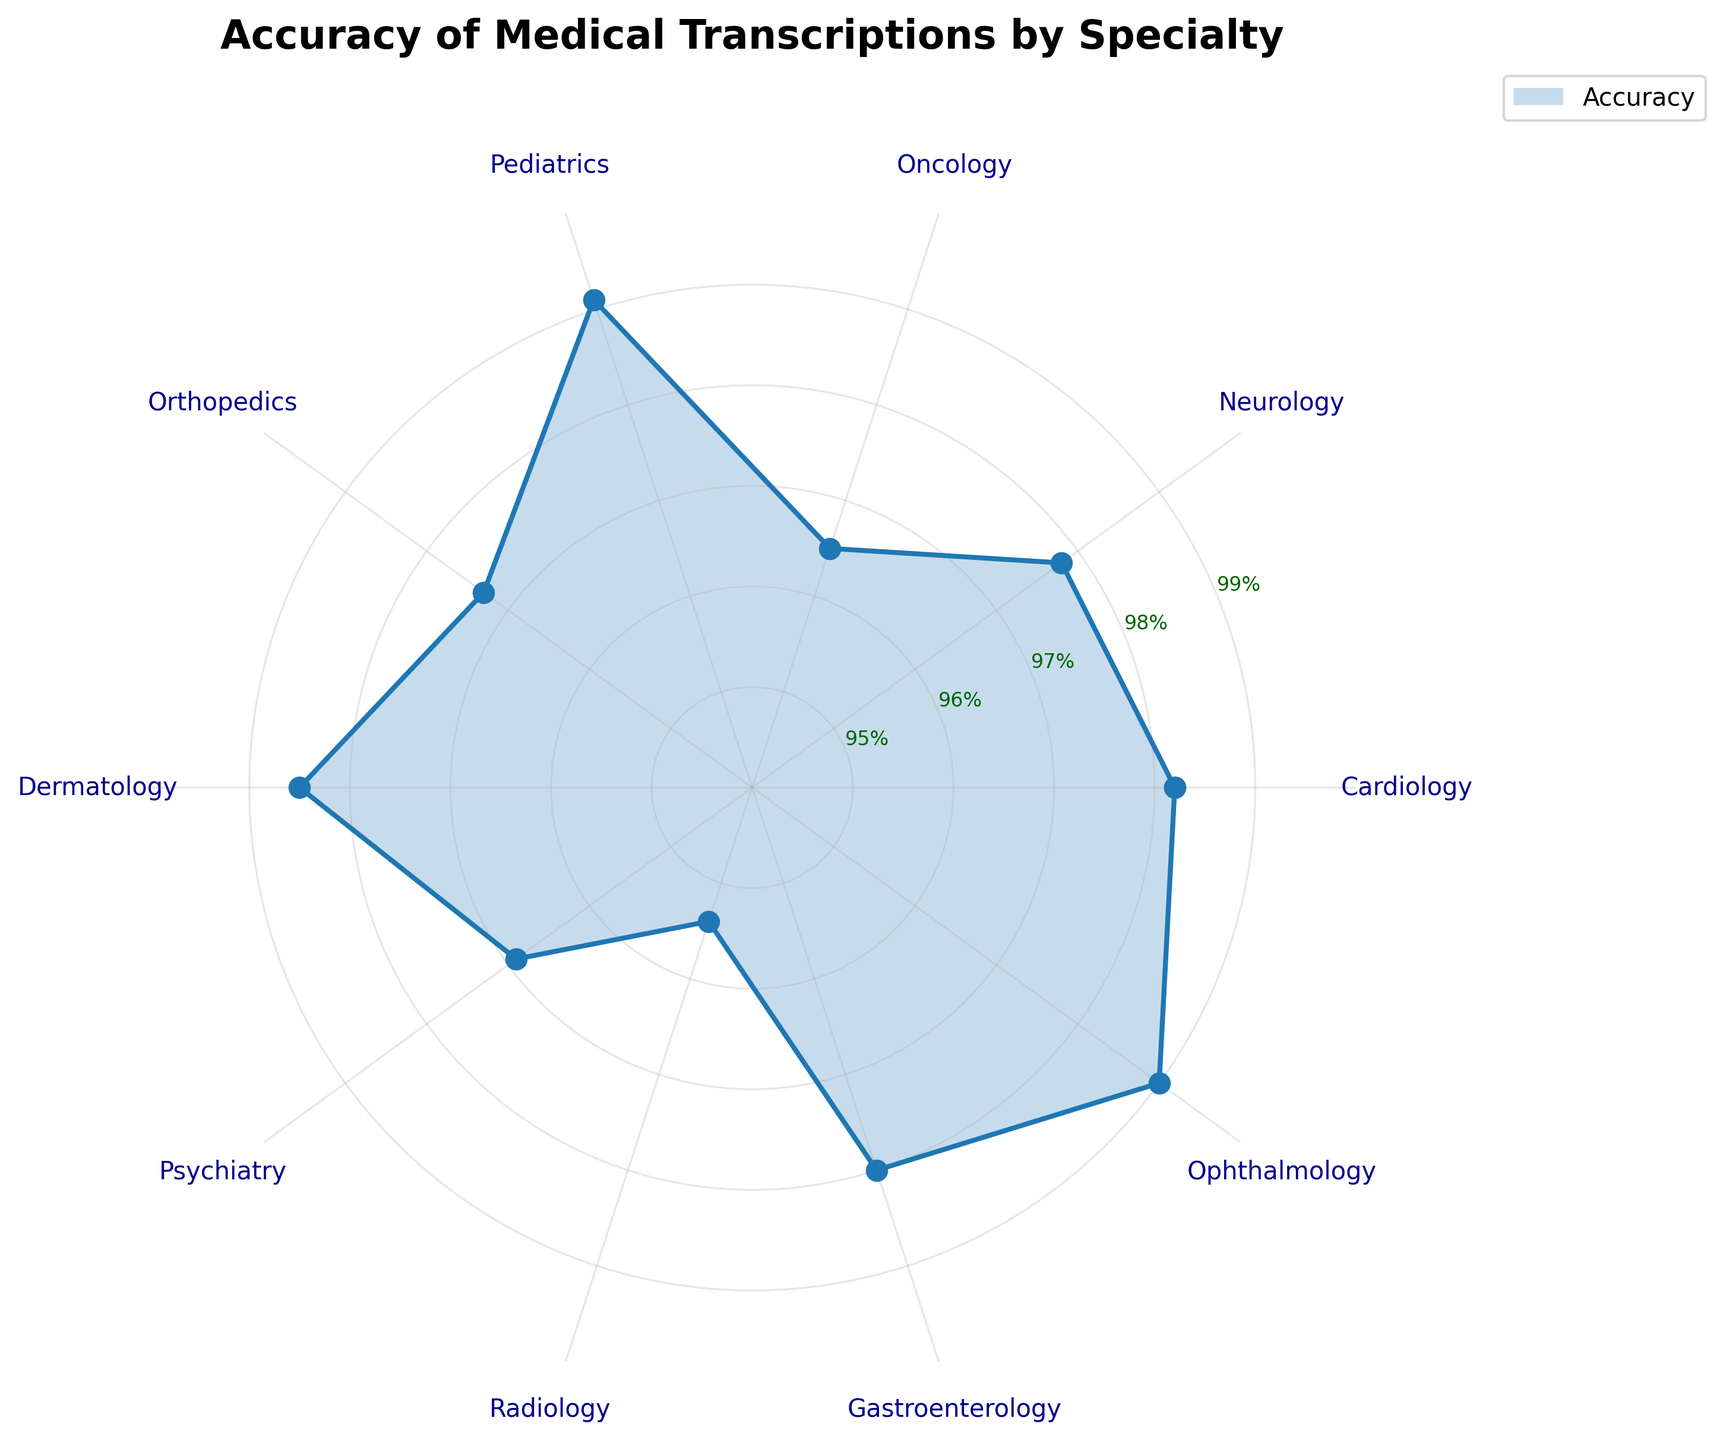What's the title of the figure? The title of the figure is typically displayed at the top and provides a summary of the chart's purpose.
Answer: Accuracy of Medical Transcriptions by Specialty How many medical specialties are represented in the figure? By counting the number of labels around the polar plot, one can see there are 10 different specialties represented.
Answer: 10 Which medical specialty has the highest accuracy in medical transcriptions? By looking at the furthest point from the center along the plot, Pediatrics shows the highest accuracy.
Answer: Pediatrics What is the accuracy percentage for Psychiatry? Find the label for Psychiatry on the polar chart and read the value indicated for it.
Answer: 96.9% Which medical specialty has the lowest accuracy in medical transcriptions? By finding the point closest to the center, Radiology has the lowest accuracy.
Answer: Radiology What is the difference in accuracy between Orthopedics and Gastroenterology? Compare the accuracy percentage of Orthopedics (97.3%) with Gastroenterology (98.0%), then subtract the lower value from the higher value. 98.0% - 97.3% = 0.7%
Answer: 0.7% What is the average accuracy of the specialties with accuracies above 98%? Identify the specialties with accuracies above 98% (Cardiology, Pediatrics, Dermatology, Ophthalmology), sum their accuracies (98.2 + 99.1 + 98.5 + 99.0), and divide by the number of those specialties. (98.2 + 99.1 + 98.5 + 99.0) / 4 = 98.7
Answer: 98.7% Which medical specialties have accuracies greater than 98% but less than 99%? Identify the specialties falling within the 98%-99% range: Cardiology (98.2%), Dermatology (98.5%), Gastroenterology (98.0%).
Answer: Cardiology, Dermatology, Gastroenterology How does the accuracy of Neurology compare to Ophthalmology? Neurology has an accuracy of 97.8%, while Ophthalmology has 99.0%. Therefore, Ophthalmology has a higher accuracy.
Answer: Ophthalmology has higher accuracy Is the accuracy of Radiology closer to 95% or 96%? Radiology's accuracy is 95.4%, which is closer to 95% than 96%.
Answer: 95% 